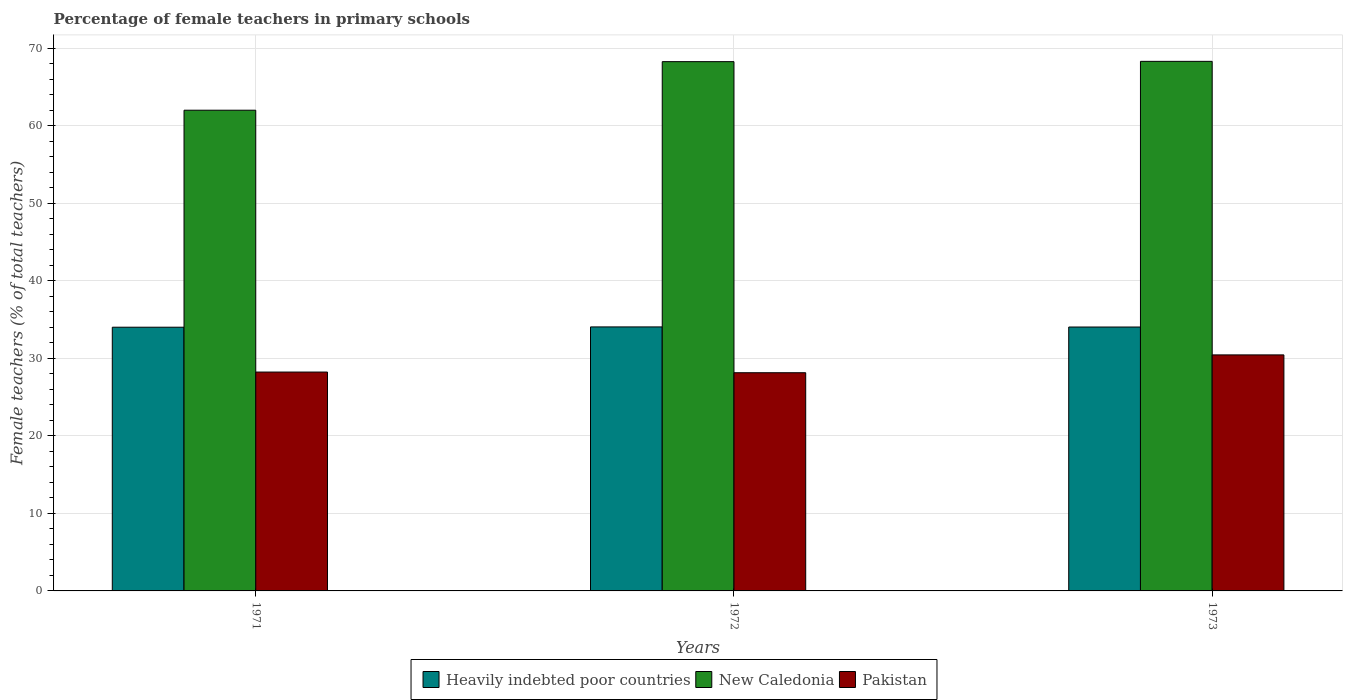How many different coloured bars are there?
Give a very brief answer. 3. Are the number of bars per tick equal to the number of legend labels?
Your response must be concise. Yes. Are the number of bars on each tick of the X-axis equal?
Give a very brief answer. Yes. How many bars are there on the 1st tick from the right?
Keep it short and to the point. 3. What is the label of the 3rd group of bars from the left?
Give a very brief answer. 1973. In how many cases, is the number of bars for a given year not equal to the number of legend labels?
Ensure brevity in your answer.  0. What is the percentage of female teachers in Heavily indebted poor countries in 1971?
Ensure brevity in your answer.  34.02. Across all years, what is the maximum percentage of female teachers in Heavily indebted poor countries?
Offer a very short reply. 34.05. Across all years, what is the minimum percentage of female teachers in Pakistan?
Offer a very short reply. 28.14. In which year was the percentage of female teachers in New Caledonia minimum?
Your answer should be very brief. 1971. What is the total percentage of female teachers in Heavily indebted poor countries in the graph?
Provide a succinct answer. 102.11. What is the difference between the percentage of female teachers in New Caledonia in 1971 and that in 1973?
Offer a very short reply. -6.3. What is the difference between the percentage of female teachers in New Caledonia in 1973 and the percentage of female teachers in Heavily indebted poor countries in 1971?
Your response must be concise. 34.29. What is the average percentage of female teachers in New Caledonia per year?
Ensure brevity in your answer.  66.19. In the year 1971, what is the difference between the percentage of female teachers in New Caledonia and percentage of female teachers in Heavily indebted poor countries?
Make the answer very short. 27.99. In how many years, is the percentage of female teachers in Pakistan greater than 54 %?
Your answer should be compact. 0. What is the ratio of the percentage of female teachers in Pakistan in 1971 to that in 1972?
Give a very brief answer. 1. Is the percentage of female teachers in Heavily indebted poor countries in 1972 less than that in 1973?
Ensure brevity in your answer.  No. Is the difference between the percentage of female teachers in New Caledonia in 1972 and 1973 greater than the difference between the percentage of female teachers in Heavily indebted poor countries in 1972 and 1973?
Provide a succinct answer. No. What is the difference between the highest and the second highest percentage of female teachers in Heavily indebted poor countries?
Keep it short and to the point. 0.01. What is the difference between the highest and the lowest percentage of female teachers in New Caledonia?
Your answer should be very brief. 6.3. What does the 3rd bar from the left in 1972 represents?
Keep it short and to the point. Pakistan. What does the 2nd bar from the right in 1972 represents?
Your response must be concise. New Caledonia. Is it the case that in every year, the sum of the percentage of female teachers in New Caledonia and percentage of female teachers in Pakistan is greater than the percentage of female teachers in Heavily indebted poor countries?
Keep it short and to the point. Yes. Are all the bars in the graph horizontal?
Offer a terse response. No. How many legend labels are there?
Your answer should be very brief. 3. What is the title of the graph?
Provide a succinct answer. Percentage of female teachers in primary schools. Does "Portugal" appear as one of the legend labels in the graph?
Keep it short and to the point. No. What is the label or title of the Y-axis?
Keep it short and to the point. Female teachers (% of total teachers). What is the Female teachers (% of total teachers) in Heavily indebted poor countries in 1971?
Your response must be concise. 34.02. What is the Female teachers (% of total teachers) in New Caledonia in 1971?
Provide a short and direct response. 62.01. What is the Female teachers (% of total teachers) in Pakistan in 1971?
Ensure brevity in your answer.  28.23. What is the Female teachers (% of total teachers) in Heavily indebted poor countries in 1972?
Provide a short and direct response. 34.05. What is the Female teachers (% of total teachers) of New Caledonia in 1972?
Offer a terse response. 68.27. What is the Female teachers (% of total teachers) of Pakistan in 1972?
Provide a succinct answer. 28.14. What is the Female teachers (% of total teachers) of Heavily indebted poor countries in 1973?
Your response must be concise. 34.04. What is the Female teachers (% of total teachers) in New Caledonia in 1973?
Your answer should be very brief. 68.31. What is the Female teachers (% of total teachers) of Pakistan in 1973?
Keep it short and to the point. 30.44. Across all years, what is the maximum Female teachers (% of total teachers) of Heavily indebted poor countries?
Your answer should be very brief. 34.05. Across all years, what is the maximum Female teachers (% of total teachers) in New Caledonia?
Your answer should be very brief. 68.31. Across all years, what is the maximum Female teachers (% of total teachers) in Pakistan?
Your answer should be compact. 30.44. Across all years, what is the minimum Female teachers (% of total teachers) of Heavily indebted poor countries?
Your answer should be very brief. 34.02. Across all years, what is the minimum Female teachers (% of total teachers) of New Caledonia?
Make the answer very short. 62.01. Across all years, what is the minimum Female teachers (% of total teachers) of Pakistan?
Provide a succinct answer. 28.14. What is the total Female teachers (% of total teachers) in Heavily indebted poor countries in the graph?
Offer a very short reply. 102.11. What is the total Female teachers (% of total teachers) in New Caledonia in the graph?
Ensure brevity in your answer.  198.58. What is the total Female teachers (% of total teachers) in Pakistan in the graph?
Give a very brief answer. 86.82. What is the difference between the Female teachers (% of total teachers) in Heavily indebted poor countries in 1971 and that in 1972?
Offer a terse response. -0.04. What is the difference between the Female teachers (% of total teachers) in New Caledonia in 1971 and that in 1972?
Keep it short and to the point. -6.26. What is the difference between the Female teachers (% of total teachers) in Pakistan in 1971 and that in 1972?
Make the answer very short. 0.09. What is the difference between the Female teachers (% of total teachers) of Heavily indebted poor countries in 1971 and that in 1973?
Offer a terse response. -0.02. What is the difference between the Female teachers (% of total teachers) in New Caledonia in 1971 and that in 1973?
Ensure brevity in your answer.  -6.3. What is the difference between the Female teachers (% of total teachers) in Pakistan in 1971 and that in 1973?
Ensure brevity in your answer.  -2.21. What is the difference between the Female teachers (% of total teachers) in Heavily indebted poor countries in 1972 and that in 1973?
Provide a succinct answer. 0.01. What is the difference between the Female teachers (% of total teachers) in New Caledonia in 1972 and that in 1973?
Offer a terse response. -0.04. What is the difference between the Female teachers (% of total teachers) of Pakistan in 1972 and that in 1973?
Ensure brevity in your answer.  -2.3. What is the difference between the Female teachers (% of total teachers) of Heavily indebted poor countries in 1971 and the Female teachers (% of total teachers) of New Caledonia in 1972?
Your response must be concise. -34.25. What is the difference between the Female teachers (% of total teachers) of Heavily indebted poor countries in 1971 and the Female teachers (% of total teachers) of Pakistan in 1972?
Keep it short and to the point. 5.87. What is the difference between the Female teachers (% of total teachers) in New Caledonia in 1971 and the Female teachers (% of total teachers) in Pakistan in 1972?
Make the answer very short. 33.86. What is the difference between the Female teachers (% of total teachers) in Heavily indebted poor countries in 1971 and the Female teachers (% of total teachers) in New Caledonia in 1973?
Provide a short and direct response. -34.29. What is the difference between the Female teachers (% of total teachers) of Heavily indebted poor countries in 1971 and the Female teachers (% of total teachers) of Pakistan in 1973?
Ensure brevity in your answer.  3.57. What is the difference between the Female teachers (% of total teachers) of New Caledonia in 1971 and the Female teachers (% of total teachers) of Pakistan in 1973?
Offer a terse response. 31.56. What is the difference between the Female teachers (% of total teachers) in Heavily indebted poor countries in 1972 and the Female teachers (% of total teachers) in New Caledonia in 1973?
Offer a terse response. -34.25. What is the difference between the Female teachers (% of total teachers) in Heavily indebted poor countries in 1972 and the Female teachers (% of total teachers) in Pakistan in 1973?
Offer a very short reply. 3.61. What is the difference between the Female teachers (% of total teachers) in New Caledonia in 1972 and the Female teachers (% of total teachers) in Pakistan in 1973?
Ensure brevity in your answer.  37.82. What is the average Female teachers (% of total teachers) in Heavily indebted poor countries per year?
Give a very brief answer. 34.04. What is the average Female teachers (% of total teachers) of New Caledonia per year?
Keep it short and to the point. 66.19. What is the average Female teachers (% of total teachers) of Pakistan per year?
Offer a terse response. 28.94. In the year 1971, what is the difference between the Female teachers (% of total teachers) in Heavily indebted poor countries and Female teachers (% of total teachers) in New Caledonia?
Make the answer very short. -27.99. In the year 1971, what is the difference between the Female teachers (% of total teachers) in Heavily indebted poor countries and Female teachers (% of total teachers) in Pakistan?
Your response must be concise. 5.79. In the year 1971, what is the difference between the Female teachers (% of total teachers) of New Caledonia and Female teachers (% of total teachers) of Pakistan?
Give a very brief answer. 33.77. In the year 1972, what is the difference between the Female teachers (% of total teachers) in Heavily indebted poor countries and Female teachers (% of total teachers) in New Caledonia?
Provide a short and direct response. -34.21. In the year 1972, what is the difference between the Female teachers (% of total teachers) of Heavily indebted poor countries and Female teachers (% of total teachers) of Pakistan?
Keep it short and to the point. 5.91. In the year 1972, what is the difference between the Female teachers (% of total teachers) of New Caledonia and Female teachers (% of total teachers) of Pakistan?
Ensure brevity in your answer.  40.13. In the year 1973, what is the difference between the Female teachers (% of total teachers) in Heavily indebted poor countries and Female teachers (% of total teachers) in New Caledonia?
Offer a terse response. -34.27. In the year 1973, what is the difference between the Female teachers (% of total teachers) of Heavily indebted poor countries and Female teachers (% of total teachers) of Pakistan?
Ensure brevity in your answer.  3.6. In the year 1973, what is the difference between the Female teachers (% of total teachers) in New Caledonia and Female teachers (% of total teachers) in Pakistan?
Provide a short and direct response. 37.86. What is the ratio of the Female teachers (% of total teachers) in New Caledonia in 1971 to that in 1972?
Keep it short and to the point. 0.91. What is the ratio of the Female teachers (% of total teachers) in Pakistan in 1971 to that in 1972?
Give a very brief answer. 1. What is the ratio of the Female teachers (% of total teachers) in Heavily indebted poor countries in 1971 to that in 1973?
Provide a succinct answer. 1. What is the ratio of the Female teachers (% of total teachers) in New Caledonia in 1971 to that in 1973?
Offer a very short reply. 0.91. What is the ratio of the Female teachers (% of total teachers) in Pakistan in 1971 to that in 1973?
Your answer should be compact. 0.93. What is the ratio of the Female teachers (% of total teachers) in Pakistan in 1972 to that in 1973?
Offer a very short reply. 0.92. What is the difference between the highest and the second highest Female teachers (% of total teachers) in Heavily indebted poor countries?
Your answer should be very brief. 0.01. What is the difference between the highest and the second highest Female teachers (% of total teachers) of New Caledonia?
Your answer should be very brief. 0.04. What is the difference between the highest and the second highest Female teachers (% of total teachers) in Pakistan?
Make the answer very short. 2.21. What is the difference between the highest and the lowest Female teachers (% of total teachers) of Heavily indebted poor countries?
Your answer should be compact. 0.04. What is the difference between the highest and the lowest Female teachers (% of total teachers) of New Caledonia?
Provide a short and direct response. 6.3. What is the difference between the highest and the lowest Female teachers (% of total teachers) in Pakistan?
Your answer should be compact. 2.3. 